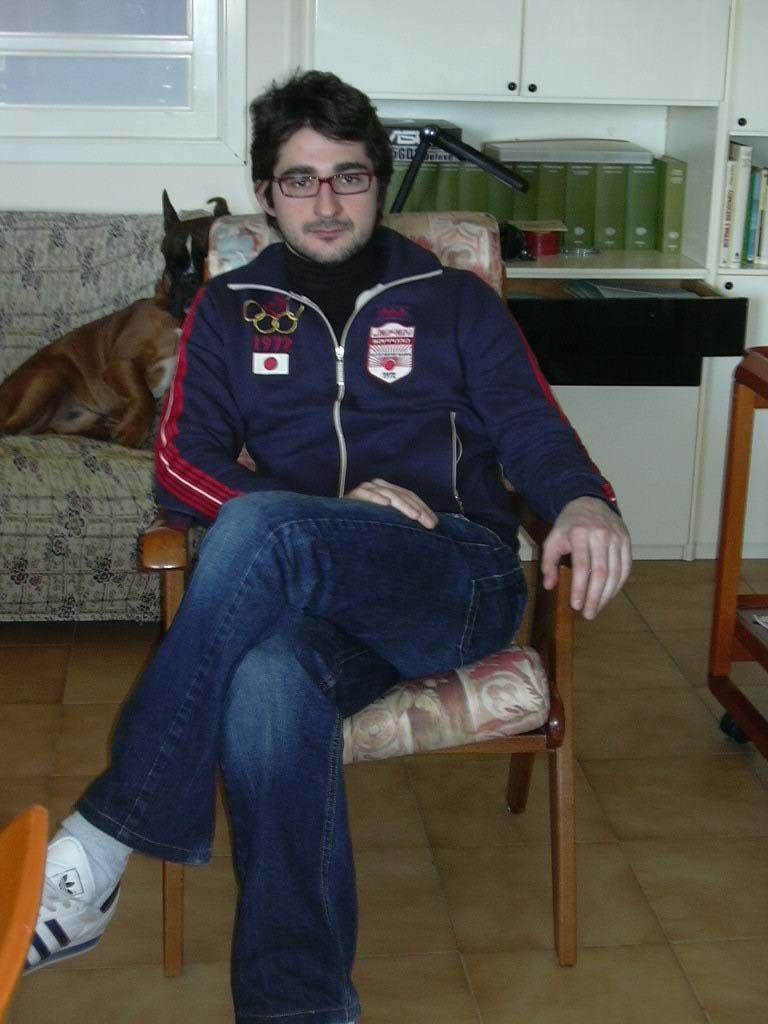What is the man in the image doing? The man is sitting on a chair in the image. Can you describe the man's appearance? The man is wearing spectacles. What can be seen on the floor in the image? The floor is visible in the image. What is the dog doing in the image? The dog is on a sofa in the image. What type of furniture is visible in the background of the image? There are cupboards in the background of the image. What else can be seen in the background of the image? There are books and a window in the background of the image. What type of wheel is attached to the dog's leg in the image? There is no wheel attached to the dog's leg in the image. How many hens are visible in the image? There are no hens present in the image. 